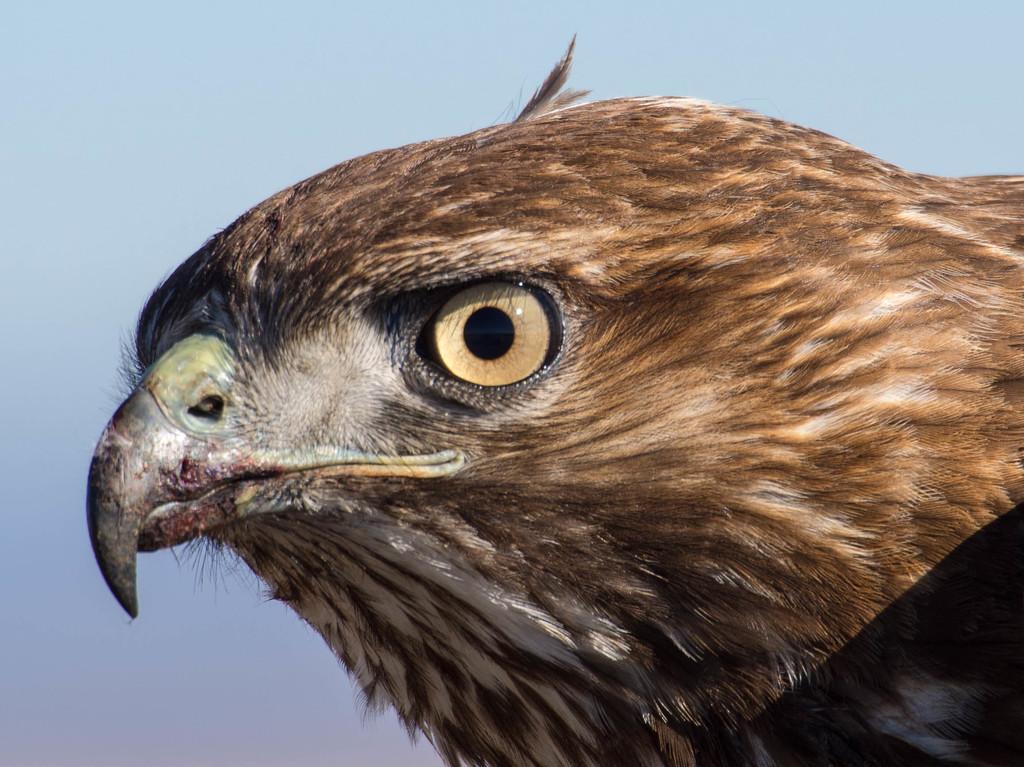Describe this image in one or two sentences. In this image, I can see the face of an eagle. I can see the beak and an eye. I think these are the feathers. The background looks light blue in color. 